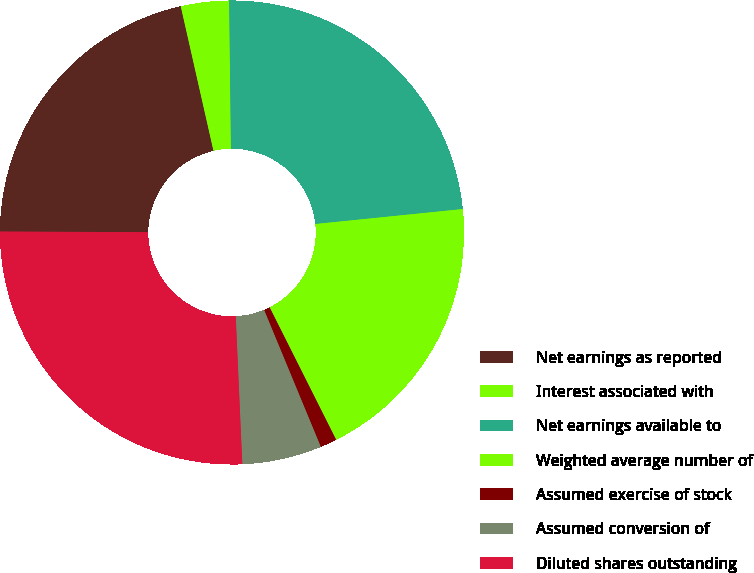Convert chart. <chart><loc_0><loc_0><loc_500><loc_500><pie_chart><fcel>Net earnings as reported<fcel>Interest associated with<fcel>Net earnings available to<fcel>Weighted average number of<fcel>Assumed exercise of stock<fcel>Assumed conversion of<fcel>Diluted shares outstanding<nl><fcel>21.39%<fcel>3.35%<fcel>23.58%<fcel>19.2%<fcel>1.16%<fcel>5.54%<fcel>25.77%<nl></chart> 